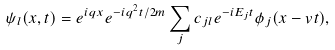Convert formula to latex. <formula><loc_0><loc_0><loc_500><loc_500>\psi _ { l } ( x , t ) = e ^ { i q x } e ^ { - i q ^ { 2 } t / 2 m } \sum _ { j } c _ { j l } e ^ { - i E _ { j } t } \phi _ { j } ( x - v t ) ,</formula> 